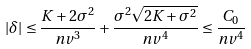Convert formula to latex. <formula><loc_0><loc_0><loc_500><loc_500>| \delta | \leq \frac { K + 2 \sigma ^ { 2 } } { n v ^ { 3 } } + \frac { \sigma ^ { 2 } \sqrt { 2 K + \sigma ^ { 2 } } } { n v ^ { 4 } } \leq \frac { C _ { 0 } } { n v ^ { 4 } }</formula> 